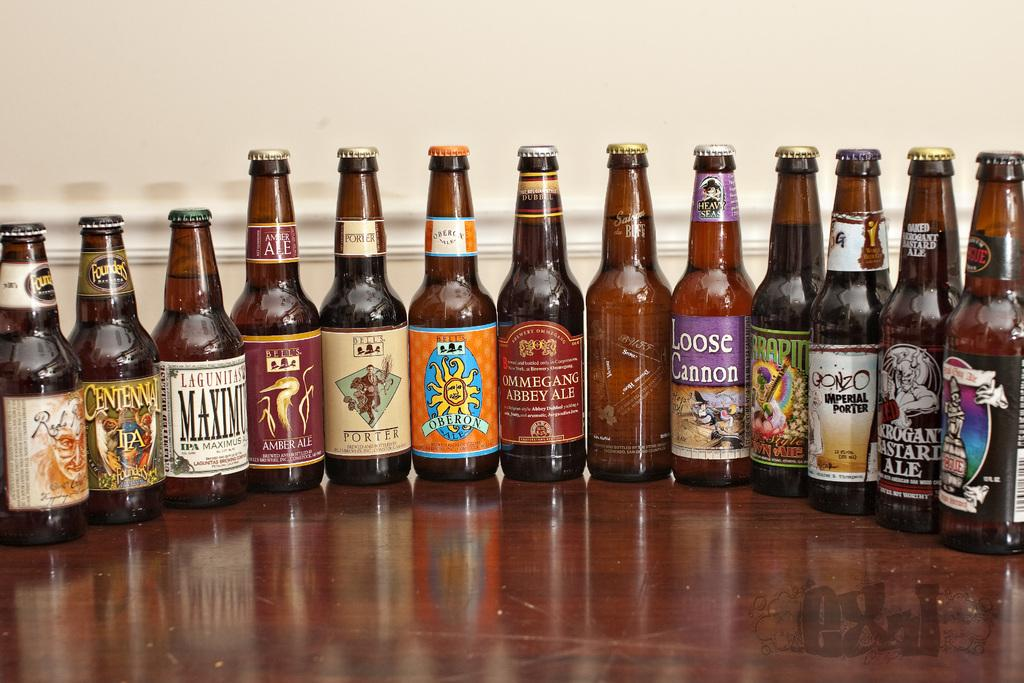<image>
Render a clear and concise summary of the photo. Thirteen different brands of Ale brewed by different companies and brands such as Loose Cannon, Ommegang Abbey Ale, Amber Ale etc 